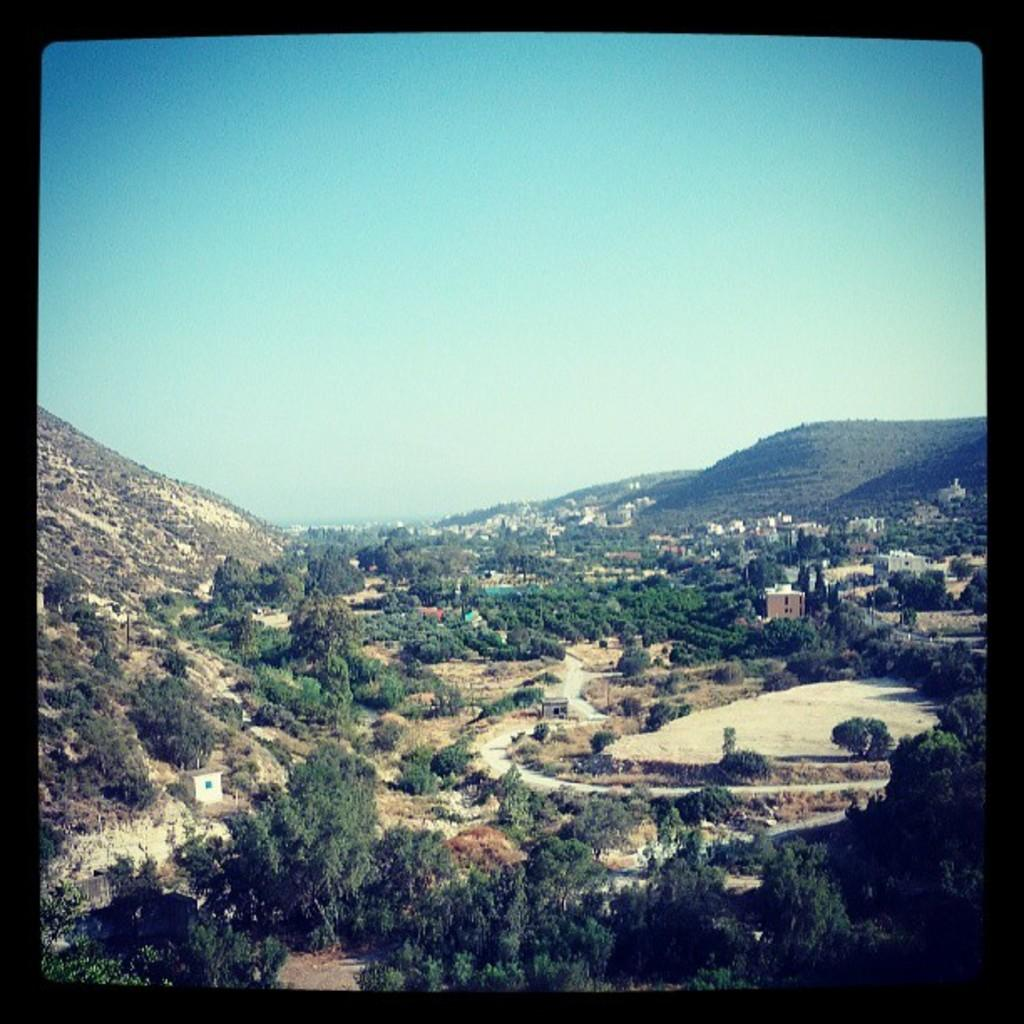What is the main subject of the image? There is a photo in the image. What can be seen in the photo? The photo contains trees, buildings, mountains, and the sky. Can you describe the landscape in the photo? The photo features a landscape with trees, buildings, mountains, and a visible sky. Where is the nest located in the photo? There is no nest present in the photo; it features a landscape with trees, buildings, mountains, and a visible sky. 